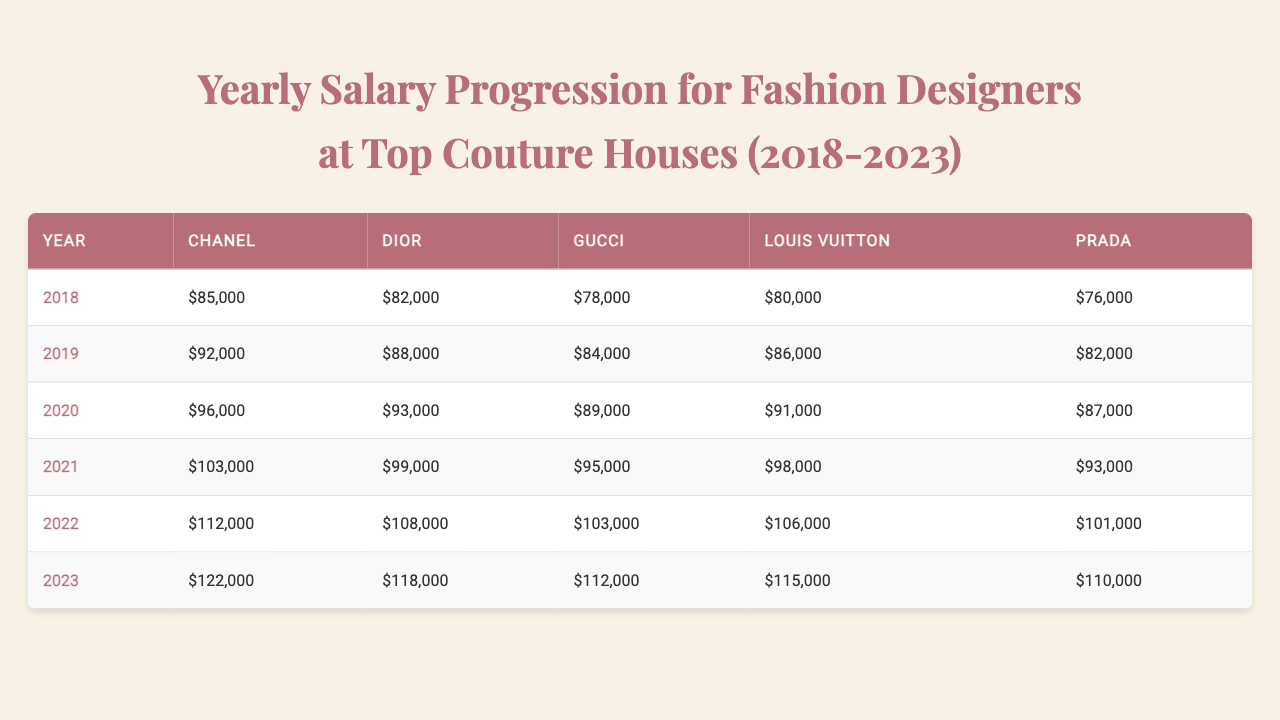What was the highest salary for a fashion designer at Chanel in 2023? The table indicates that the salary for Chanel in 2023 is $122,000, which is the highest figure presented for that year.
Answer: $122,000 What was the average salary of fashion designers at Louis Vuitton from 2018 to 2023? The salaries for Louis Vuitton from 2018 to 2023 are $80,000, $86,000, $91,000, $98,000, $106,000, and $115,000. The sum is $576,000, and there are 6 data points, so the average is $576,000 / 6 = $96,000.
Answer: $96,000 Did Dior have a higher salary than Prada in 2022? According to the table, Dior's salary in 2022 is $108,000, and Prada's is $101,000. Since $108,000 is greater than $101,000, the answer is yes.
Answer: Yes What is the total salary increase for Gucci from 2018 to 2023? The salary for Gucci in 2018 is $78,000 and in 2023 it is $112,000. To find the total increase, subtract the 2018 salary from the 2023 salary: $112,000 - $78,000 = $34,000.
Answer: $34,000 Which couture house had the highest percentage salary increase from 2018 to 2023? Chanel's salary increased from $85,000 in 2018 to $122,000 in 2023, which represents an increase of $37,000. To calculate the percentage increase: ($37,000 / $85,000) * 100 ≈ 43.53%. For Dior, the increase is $36,000 (from $82,000 to $118,000), giving a percentage of about 43.90%. The calculations show Dior had a slightly higher percentage increase. Therefore, Dior had the highest percentage increase between 2018 and 2023.
Answer: Dior What was the highest salary recorded in the table for any fashion designer in any year? Reviewing the entire table, the highest salary recorded is $122,000 for Chanel in 2023.
Answer: $122,000 How much total did all designers earn in 2020? The salaries for all designers in 2020 are $96,000 (Chanel), $93,000 (Dior), $89,000 (Gucci), $91,000 (Louis Vuitton), and $87,000 (Prada). Summing these amounts gives $96,000 + $93,000 + $89,000 + $91,000 + $87,000 = $456,000.
Answer: $456,000 What was the minimum salary for Gucci throughout the years in the table? The lowest salary for Gucci is recorded at $78,000 in 2018, which is less than the other years listed for Gucci.
Answer: $78,000 Which fashion house consistently had the lowest salaries from 2018 to 2023? By comparing the salaries across all years, we find that Prada's salaries are lower than those of other fashion houses in each year listed. Therefore, Prada consistently had the lowest salaries.
Answer: Prada 